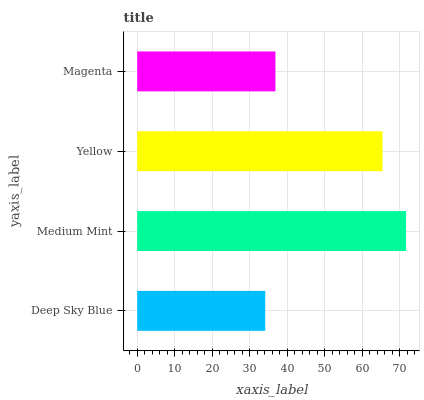Is Deep Sky Blue the minimum?
Answer yes or no. Yes. Is Medium Mint the maximum?
Answer yes or no. Yes. Is Yellow the minimum?
Answer yes or no. No. Is Yellow the maximum?
Answer yes or no. No. Is Medium Mint greater than Yellow?
Answer yes or no. Yes. Is Yellow less than Medium Mint?
Answer yes or no. Yes. Is Yellow greater than Medium Mint?
Answer yes or no. No. Is Medium Mint less than Yellow?
Answer yes or no. No. Is Yellow the high median?
Answer yes or no. Yes. Is Magenta the low median?
Answer yes or no. Yes. Is Medium Mint the high median?
Answer yes or no. No. Is Deep Sky Blue the low median?
Answer yes or no. No. 